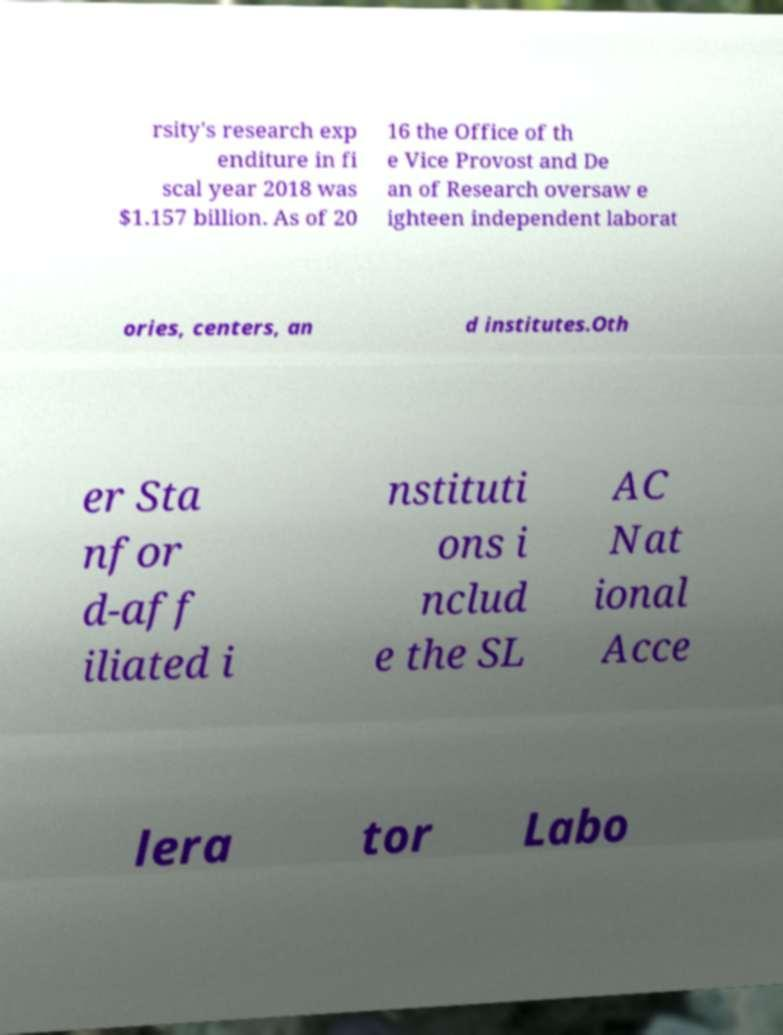There's text embedded in this image that I need extracted. Can you transcribe it verbatim? rsity's research exp enditure in fi scal year 2018 was $1.157 billion. As of 20 16 the Office of th e Vice Provost and De an of Research oversaw e ighteen independent laborat ories, centers, an d institutes.Oth er Sta nfor d-aff iliated i nstituti ons i nclud e the SL AC Nat ional Acce lera tor Labo 